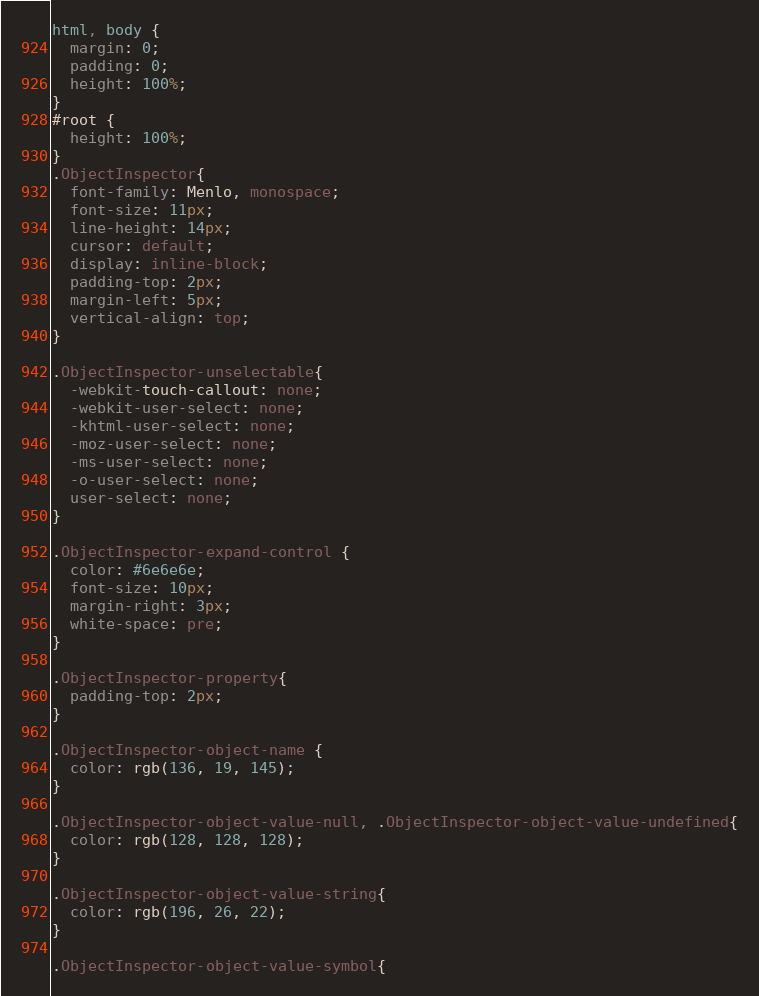Convert code to text. <code><loc_0><loc_0><loc_500><loc_500><_CSS_>html, body {
  margin: 0;
  padding: 0;
  height: 100%;
}
#root {
  height: 100%;
}
.ObjectInspector{
  font-family: Menlo, monospace;
  font-size: 11px;
  line-height: 14px;
  cursor: default;
  display: inline-block;
  padding-top: 2px;
  margin-left: 5px;
  vertical-align: top;
}

.ObjectInspector-unselectable{
  -webkit-touch-callout: none;
  -webkit-user-select: none;
  -khtml-user-select: none;
  -moz-user-select: none;
  -ms-user-select: none;
  -o-user-select: none;
  user-select: none;
}

.ObjectInspector-expand-control {
  color: #6e6e6e;
  font-size: 10px;
  margin-right: 3px;
  white-space: pre;
}

.ObjectInspector-property{
  padding-top: 2px;
}

.ObjectInspector-object-name {
  color: rgb(136, 19, 145);
}

.ObjectInspector-object-value-null, .ObjectInspector-object-value-undefined{
  color: rgb(128, 128, 128);
}

.ObjectInspector-object-value-string{
  color: rgb(196, 26, 22);
}

.ObjectInspector-object-value-symbol{</code> 